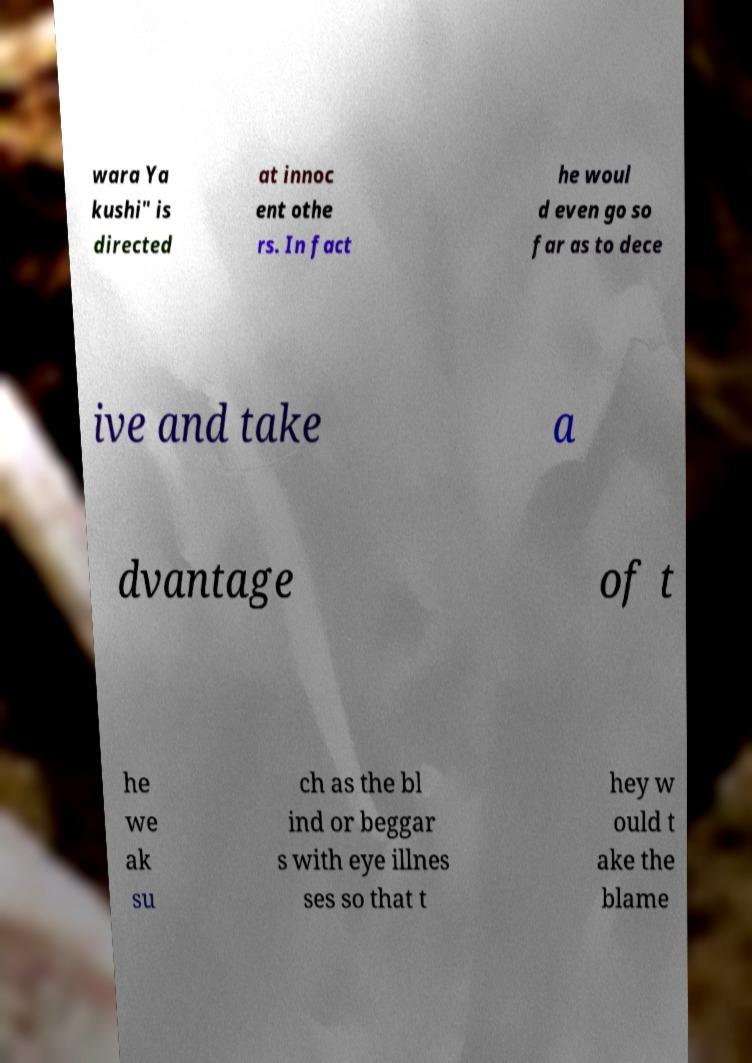Please identify and transcribe the text found in this image. wara Ya kushi" is directed at innoc ent othe rs. In fact he woul d even go so far as to dece ive and take a dvantage of t he we ak su ch as the bl ind or beggar s with eye illnes ses so that t hey w ould t ake the blame 